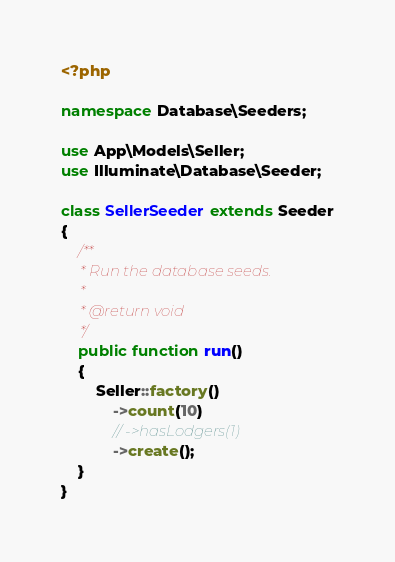<code> <loc_0><loc_0><loc_500><loc_500><_PHP_><?php

namespace Database\Seeders;

use App\Models\Seller;
use Illuminate\Database\Seeder;

class SellerSeeder extends Seeder
{
    /**
     * Run the database seeds.
     *
     * @return void
     */
    public function run()
    {
        Seller::factory()
            ->count(10)
            // ->hasLodgers(1)
            ->create();
    }
}
</code> 